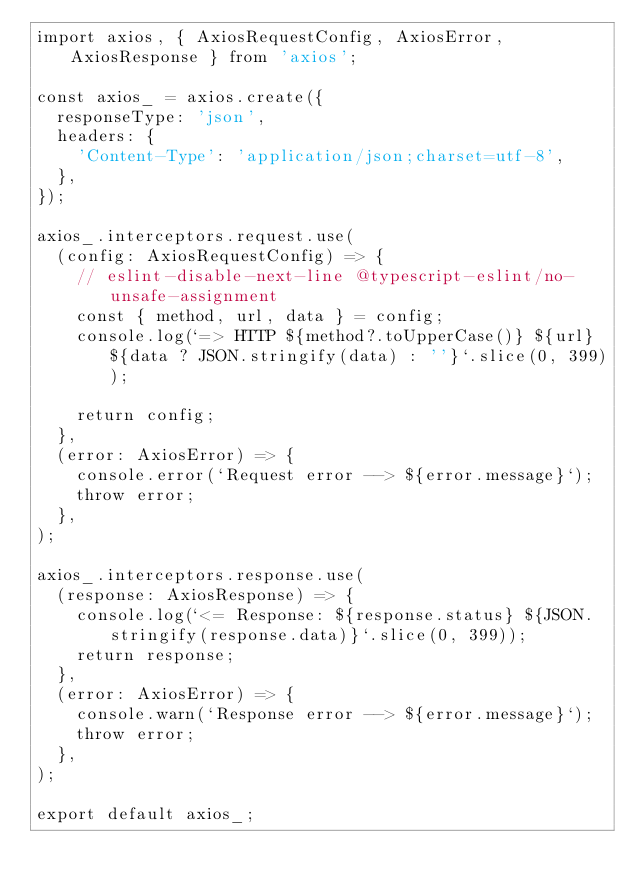<code> <loc_0><loc_0><loc_500><loc_500><_TypeScript_>import axios, { AxiosRequestConfig, AxiosError, AxiosResponse } from 'axios';

const axios_ = axios.create({
  responseType: 'json',
  headers: {
    'Content-Type': 'application/json;charset=utf-8',
  },
});

axios_.interceptors.request.use(
  (config: AxiosRequestConfig) => {
    // eslint-disable-next-line @typescript-eslint/no-unsafe-assignment
    const { method, url, data } = config;
    console.log(`=> HTTP ${method?.toUpperCase()} ${url} ${data ? JSON.stringify(data) : ''}`.slice(0, 399));

    return config;
  },
  (error: AxiosError) => {
    console.error(`Request error --> ${error.message}`);
    throw error;
  },
);

axios_.interceptors.response.use(
  (response: AxiosResponse) => {
    console.log(`<= Response: ${response.status} ${JSON.stringify(response.data)}`.slice(0, 399));
    return response;
  },
  (error: AxiosError) => {
    console.warn(`Response error --> ${error.message}`);
    throw error;
  },
);

export default axios_;
</code> 